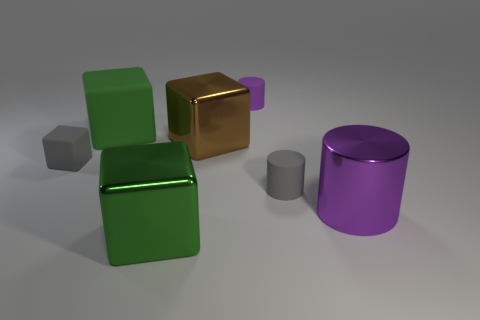Add 3 brown blocks. How many objects exist? 10 Subtract all cylinders. How many objects are left? 4 Add 5 small blue rubber cubes. How many small blue rubber cubes exist? 5 Subtract 1 green blocks. How many objects are left? 6 Subtract all big purple matte cubes. Subtract all brown things. How many objects are left? 6 Add 5 gray matte cubes. How many gray matte cubes are left? 6 